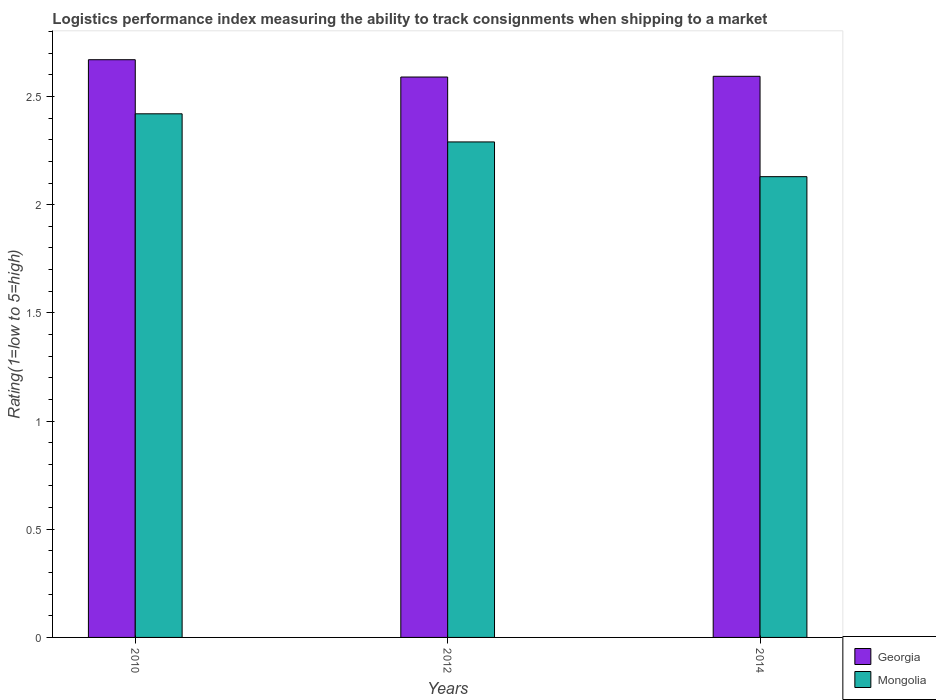How many groups of bars are there?
Give a very brief answer. 3. Are the number of bars per tick equal to the number of legend labels?
Make the answer very short. Yes. Are the number of bars on each tick of the X-axis equal?
Offer a terse response. Yes. How many bars are there on the 3rd tick from the right?
Your answer should be compact. 2. What is the label of the 3rd group of bars from the left?
Ensure brevity in your answer.  2014. In how many cases, is the number of bars for a given year not equal to the number of legend labels?
Offer a terse response. 0. What is the Logistic performance index in Georgia in 2010?
Give a very brief answer. 2.67. Across all years, what is the maximum Logistic performance index in Georgia?
Your answer should be compact. 2.67. Across all years, what is the minimum Logistic performance index in Georgia?
Make the answer very short. 2.59. In which year was the Logistic performance index in Mongolia maximum?
Ensure brevity in your answer.  2010. In which year was the Logistic performance index in Georgia minimum?
Provide a short and direct response. 2012. What is the total Logistic performance index in Georgia in the graph?
Offer a very short reply. 7.85. What is the difference between the Logistic performance index in Mongolia in 2010 and that in 2012?
Make the answer very short. 0.13. What is the difference between the Logistic performance index in Mongolia in 2010 and the Logistic performance index in Georgia in 2014?
Your response must be concise. -0.17. What is the average Logistic performance index in Georgia per year?
Your answer should be very brief. 2.62. In the year 2014, what is the difference between the Logistic performance index in Mongolia and Logistic performance index in Georgia?
Provide a succinct answer. -0.46. In how many years, is the Logistic performance index in Mongolia greater than 2.7?
Offer a very short reply. 0. What is the ratio of the Logistic performance index in Georgia in 2012 to that in 2014?
Offer a very short reply. 1. Is the Logistic performance index in Georgia in 2012 less than that in 2014?
Make the answer very short. Yes. What is the difference between the highest and the second highest Logistic performance index in Georgia?
Keep it short and to the point. 0.08. What is the difference between the highest and the lowest Logistic performance index in Mongolia?
Your response must be concise. 0.29. In how many years, is the Logistic performance index in Mongolia greater than the average Logistic performance index in Mongolia taken over all years?
Offer a very short reply. 2. Is the sum of the Logistic performance index in Mongolia in 2010 and 2012 greater than the maximum Logistic performance index in Georgia across all years?
Your answer should be compact. Yes. What does the 1st bar from the left in 2014 represents?
Your response must be concise. Georgia. What does the 1st bar from the right in 2012 represents?
Ensure brevity in your answer.  Mongolia. How many years are there in the graph?
Your answer should be compact. 3. Does the graph contain any zero values?
Give a very brief answer. No. Where does the legend appear in the graph?
Provide a short and direct response. Bottom right. How are the legend labels stacked?
Offer a terse response. Vertical. What is the title of the graph?
Make the answer very short. Logistics performance index measuring the ability to track consignments when shipping to a market. Does "Tanzania" appear as one of the legend labels in the graph?
Give a very brief answer. No. What is the label or title of the Y-axis?
Make the answer very short. Rating(1=low to 5=high). What is the Rating(1=low to 5=high) of Georgia in 2010?
Offer a very short reply. 2.67. What is the Rating(1=low to 5=high) in Mongolia in 2010?
Your answer should be compact. 2.42. What is the Rating(1=low to 5=high) in Georgia in 2012?
Provide a succinct answer. 2.59. What is the Rating(1=low to 5=high) in Mongolia in 2012?
Ensure brevity in your answer.  2.29. What is the Rating(1=low to 5=high) of Georgia in 2014?
Offer a very short reply. 2.59. What is the Rating(1=low to 5=high) of Mongolia in 2014?
Make the answer very short. 2.13. Across all years, what is the maximum Rating(1=low to 5=high) of Georgia?
Keep it short and to the point. 2.67. Across all years, what is the maximum Rating(1=low to 5=high) in Mongolia?
Offer a very short reply. 2.42. Across all years, what is the minimum Rating(1=low to 5=high) of Georgia?
Your answer should be compact. 2.59. Across all years, what is the minimum Rating(1=low to 5=high) of Mongolia?
Ensure brevity in your answer.  2.13. What is the total Rating(1=low to 5=high) in Georgia in the graph?
Make the answer very short. 7.85. What is the total Rating(1=low to 5=high) in Mongolia in the graph?
Your answer should be very brief. 6.84. What is the difference between the Rating(1=low to 5=high) of Georgia in 2010 and that in 2012?
Your answer should be compact. 0.08. What is the difference between the Rating(1=low to 5=high) of Mongolia in 2010 and that in 2012?
Provide a short and direct response. 0.13. What is the difference between the Rating(1=low to 5=high) of Georgia in 2010 and that in 2014?
Offer a very short reply. 0.08. What is the difference between the Rating(1=low to 5=high) of Mongolia in 2010 and that in 2014?
Your answer should be very brief. 0.29. What is the difference between the Rating(1=low to 5=high) in Georgia in 2012 and that in 2014?
Keep it short and to the point. -0. What is the difference between the Rating(1=low to 5=high) in Mongolia in 2012 and that in 2014?
Offer a very short reply. 0.16. What is the difference between the Rating(1=low to 5=high) of Georgia in 2010 and the Rating(1=low to 5=high) of Mongolia in 2012?
Give a very brief answer. 0.38. What is the difference between the Rating(1=low to 5=high) of Georgia in 2010 and the Rating(1=low to 5=high) of Mongolia in 2014?
Give a very brief answer. 0.54. What is the difference between the Rating(1=low to 5=high) of Georgia in 2012 and the Rating(1=low to 5=high) of Mongolia in 2014?
Give a very brief answer. 0.46. What is the average Rating(1=low to 5=high) in Georgia per year?
Give a very brief answer. 2.62. What is the average Rating(1=low to 5=high) of Mongolia per year?
Make the answer very short. 2.28. In the year 2010, what is the difference between the Rating(1=low to 5=high) of Georgia and Rating(1=low to 5=high) of Mongolia?
Your response must be concise. 0.25. In the year 2014, what is the difference between the Rating(1=low to 5=high) of Georgia and Rating(1=low to 5=high) of Mongolia?
Provide a succinct answer. 0.46. What is the ratio of the Rating(1=low to 5=high) of Georgia in 2010 to that in 2012?
Provide a succinct answer. 1.03. What is the ratio of the Rating(1=low to 5=high) of Mongolia in 2010 to that in 2012?
Ensure brevity in your answer.  1.06. What is the ratio of the Rating(1=low to 5=high) in Georgia in 2010 to that in 2014?
Give a very brief answer. 1.03. What is the ratio of the Rating(1=low to 5=high) of Mongolia in 2010 to that in 2014?
Make the answer very short. 1.14. What is the ratio of the Rating(1=low to 5=high) of Mongolia in 2012 to that in 2014?
Offer a very short reply. 1.08. What is the difference between the highest and the second highest Rating(1=low to 5=high) of Georgia?
Give a very brief answer. 0.08. What is the difference between the highest and the second highest Rating(1=low to 5=high) of Mongolia?
Offer a very short reply. 0.13. What is the difference between the highest and the lowest Rating(1=low to 5=high) of Mongolia?
Make the answer very short. 0.29. 